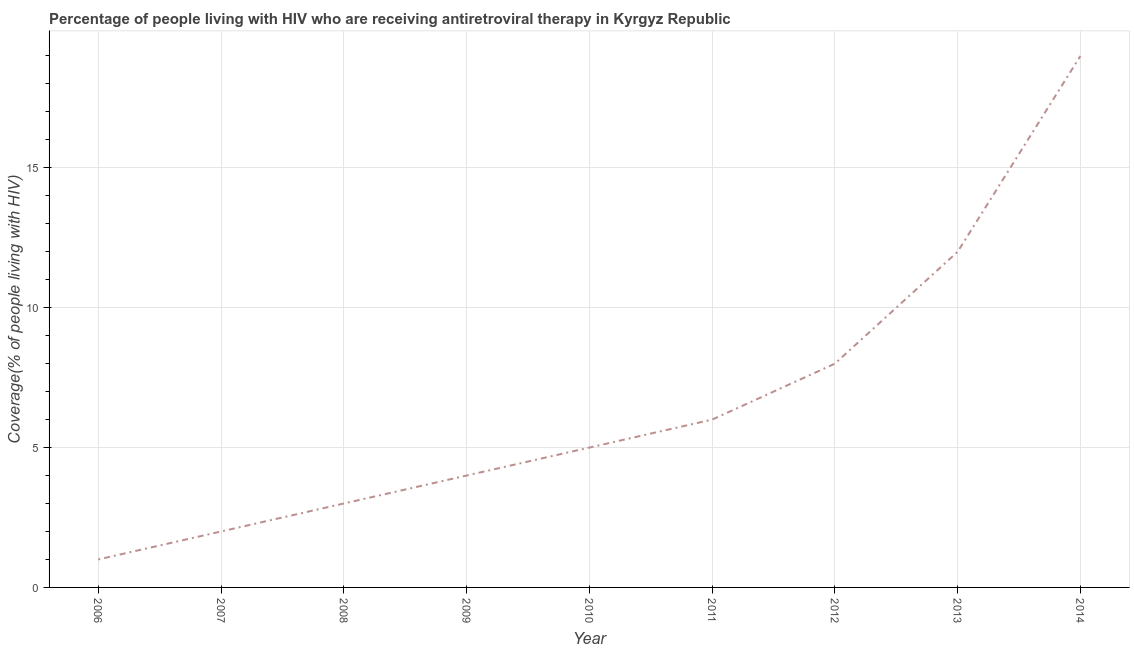What is the antiretroviral therapy coverage in 2009?
Offer a very short reply. 4. Across all years, what is the maximum antiretroviral therapy coverage?
Your answer should be compact. 19. Across all years, what is the minimum antiretroviral therapy coverage?
Your answer should be compact. 1. In which year was the antiretroviral therapy coverage minimum?
Give a very brief answer. 2006. What is the sum of the antiretroviral therapy coverage?
Offer a very short reply. 60. What is the difference between the antiretroviral therapy coverage in 2009 and 2012?
Make the answer very short. -4. What is the average antiretroviral therapy coverage per year?
Your response must be concise. 6.67. Do a majority of the years between 2010 and 2014 (inclusive) have antiretroviral therapy coverage greater than 10 %?
Keep it short and to the point. No. What is the ratio of the antiretroviral therapy coverage in 2008 to that in 2013?
Your response must be concise. 0.25. Is the antiretroviral therapy coverage in 2007 less than that in 2011?
Give a very brief answer. Yes. Is the difference between the antiretroviral therapy coverage in 2008 and 2014 greater than the difference between any two years?
Offer a terse response. No. What is the difference between the highest and the second highest antiretroviral therapy coverage?
Your response must be concise. 7. Is the sum of the antiretroviral therapy coverage in 2007 and 2009 greater than the maximum antiretroviral therapy coverage across all years?
Your answer should be compact. No. What is the difference between the highest and the lowest antiretroviral therapy coverage?
Your response must be concise. 18. In how many years, is the antiretroviral therapy coverage greater than the average antiretroviral therapy coverage taken over all years?
Provide a succinct answer. 3. Does the antiretroviral therapy coverage monotonically increase over the years?
Ensure brevity in your answer.  Yes. How many lines are there?
Ensure brevity in your answer.  1. Are the values on the major ticks of Y-axis written in scientific E-notation?
Make the answer very short. No. What is the title of the graph?
Provide a succinct answer. Percentage of people living with HIV who are receiving antiretroviral therapy in Kyrgyz Republic. What is the label or title of the Y-axis?
Provide a succinct answer. Coverage(% of people living with HIV). What is the Coverage(% of people living with HIV) in 2009?
Offer a very short reply. 4. What is the Coverage(% of people living with HIV) in 2010?
Offer a very short reply. 5. What is the Coverage(% of people living with HIV) of 2011?
Keep it short and to the point. 6. What is the Coverage(% of people living with HIV) in 2012?
Ensure brevity in your answer.  8. What is the Coverage(% of people living with HIV) in 2014?
Give a very brief answer. 19. What is the difference between the Coverage(% of people living with HIV) in 2006 and 2011?
Offer a very short reply. -5. What is the difference between the Coverage(% of people living with HIV) in 2006 and 2014?
Offer a very short reply. -18. What is the difference between the Coverage(% of people living with HIV) in 2007 and 2008?
Your answer should be compact. -1. What is the difference between the Coverage(% of people living with HIV) in 2007 and 2011?
Offer a terse response. -4. What is the difference between the Coverage(% of people living with HIV) in 2007 and 2014?
Give a very brief answer. -17. What is the difference between the Coverage(% of people living with HIV) in 2008 and 2010?
Provide a succinct answer. -2. What is the difference between the Coverage(% of people living with HIV) in 2008 and 2012?
Make the answer very short. -5. What is the difference between the Coverage(% of people living with HIV) in 2008 and 2013?
Offer a very short reply. -9. What is the difference between the Coverage(% of people living with HIV) in 2009 and 2012?
Offer a terse response. -4. What is the difference between the Coverage(% of people living with HIV) in 2009 and 2014?
Your answer should be very brief. -15. What is the difference between the Coverage(% of people living with HIV) in 2010 and 2014?
Keep it short and to the point. -14. What is the difference between the Coverage(% of people living with HIV) in 2012 and 2013?
Make the answer very short. -4. What is the difference between the Coverage(% of people living with HIV) in 2013 and 2014?
Provide a succinct answer. -7. What is the ratio of the Coverage(% of people living with HIV) in 2006 to that in 2008?
Provide a short and direct response. 0.33. What is the ratio of the Coverage(% of people living with HIV) in 2006 to that in 2011?
Your answer should be very brief. 0.17. What is the ratio of the Coverage(% of people living with HIV) in 2006 to that in 2012?
Your answer should be compact. 0.12. What is the ratio of the Coverage(% of people living with HIV) in 2006 to that in 2013?
Your response must be concise. 0.08. What is the ratio of the Coverage(% of people living with HIV) in 2006 to that in 2014?
Provide a succinct answer. 0.05. What is the ratio of the Coverage(% of people living with HIV) in 2007 to that in 2008?
Ensure brevity in your answer.  0.67. What is the ratio of the Coverage(% of people living with HIV) in 2007 to that in 2011?
Your answer should be very brief. 0.33. What is the ratio of the Coverage(% of people living with HIV) in 2007 to that in 2013?
Offer a very short reply. 0.17. What is the ratio of the Coverage(% of people living with HIV) in 2007 to that in 2014?
Ensure brevity in your answer.  0.1. What is the ratio of the Coverage(% of people living with HIV) in 2008 to that in 2010?
Offer a terse response. 0.6. What is the ratio of the Coverage(% of people living with HIV) in 2008 to that in 2011?
Keep it short and to the point. 0.5. What is the ratio of the Coverage(% of people living with HIV) in 2008 to that in 2012?
Your answer should be compact. 0.38. What is the ratio of the Coverage(% of people living with HIV) in 2008 to that in 2013?
Make the answer very short. 0.25. What is the ratio of the Coverage(% of people living with HIV) in 2008 to that in 2014?
Offer a very short reply. 0.16. What is the ratio of the Coverage(% of people living with HIV) in 2009 to that in 2010?
Make the answer very short. 0.8. What is the ratio of the Coverage(% of people living with HIV) in 2009 to that in 2011?
Offer a terse response. 0.67. What is the ratio of the Coverage(% of people living with HIV) in 2009 to that in 2012?
Make the answer very short. 0.5. What is the ratio of the Coverage(% of people living with HIV) in 2009 to that in 2013?
Provide a succinct answer. 0.33. What is the ratio of the Coverage(% of people living with HIV) in 2009 to that in 2014?
Offer a very short reply. 0.21. What is the ratio of the Coverage(% of people living with HIV) in 2010 to that in 2011?
Ensure brevity in your answer.  0.83. What is the ratio of the Coverage(% of people living with HIV) in 2010 to that in 2012?
Your response must be concise. 0.62. What is the ratio of the Coverage(% of people living with HIV) in 2010 to that in 2013?
Offer a terse response. 0.42. What is the ratio of the Coverage(% of people living with HIV) in 2010 to that in 2014?
Your answer should be compact. 0.26. What is the ratio of the Coverage(% of people living with HIV) in 2011 to that in 2013?
Offer a terse response. 0.5. What is the ratio of the Coverage(% of people living with HIV) in 2011 to that in 2014?
Provide a succinct answer. 0.32. What is the ratio of the Coverage(% of people living with HIV) in 2012 to that in 2013?
Your response must be concise. 0.67. What is the ratio of the Coverage(% of people living with HIV) in 2012 to that in 2014?
Your answer should be compact. 0.42. What is the ratio of the Coverage(% of people living with HIV) in 2013 to that in 2014?
Keep it short and to the point. 0.63. 